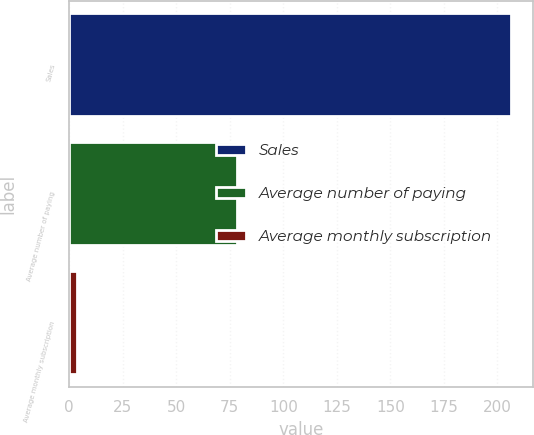<chart> <loc_0><loc_0><loc_500><loc_500><bar_chart><fcel>Sales<fcel>Average number of paying<fcel>Average monthly subscription<nl><fcel>206.4<fcel>78.3<fcel>3.8<nl></chart> 